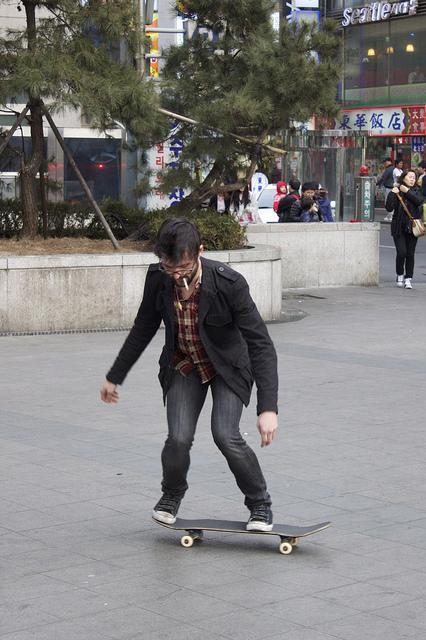How many people are in the picture?
Give a very brief answer. 2. How many numbers are on the clock tower?
Give a very brief answer. 0. 